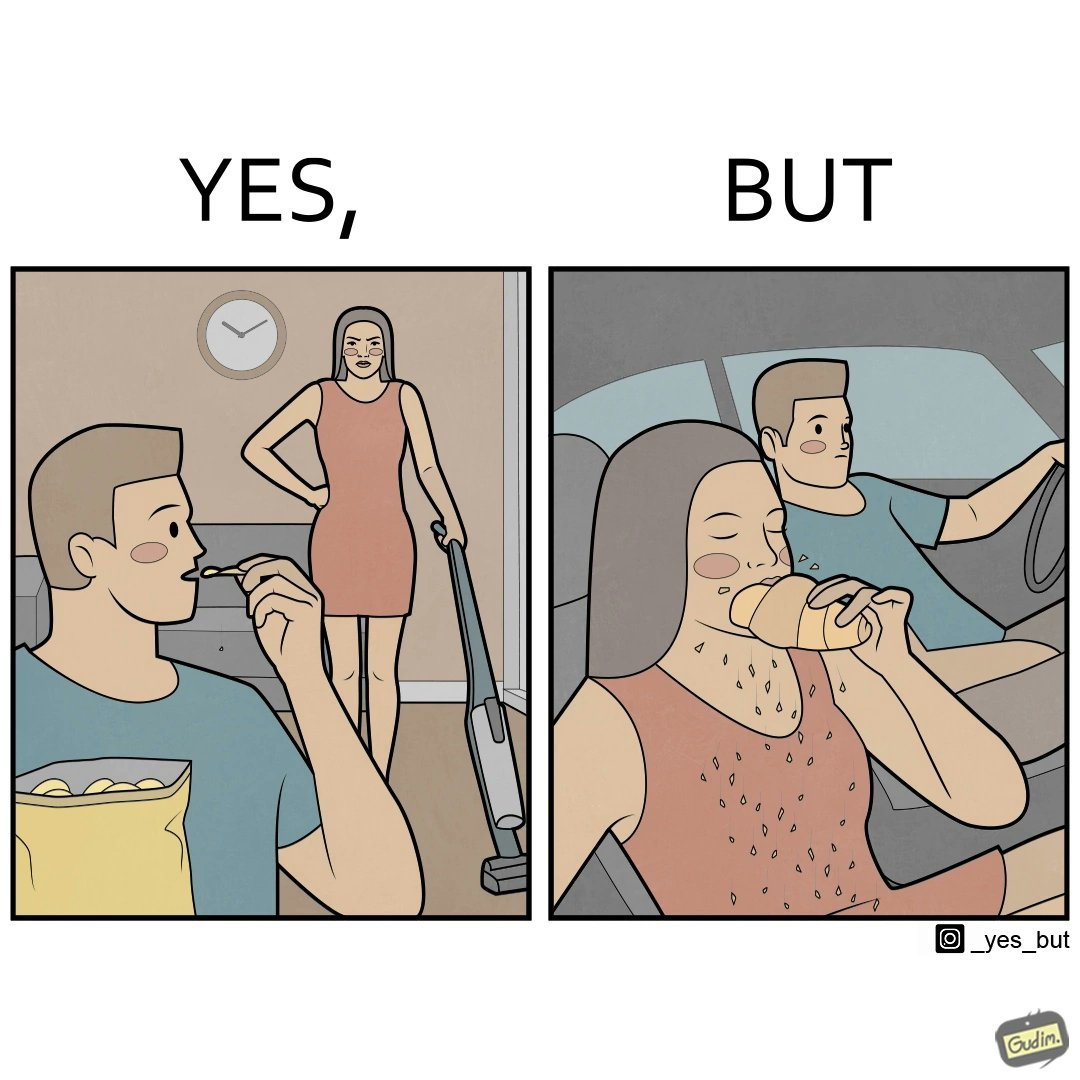Is this image satirical or non-satirical? Yes, this image is satirical. 